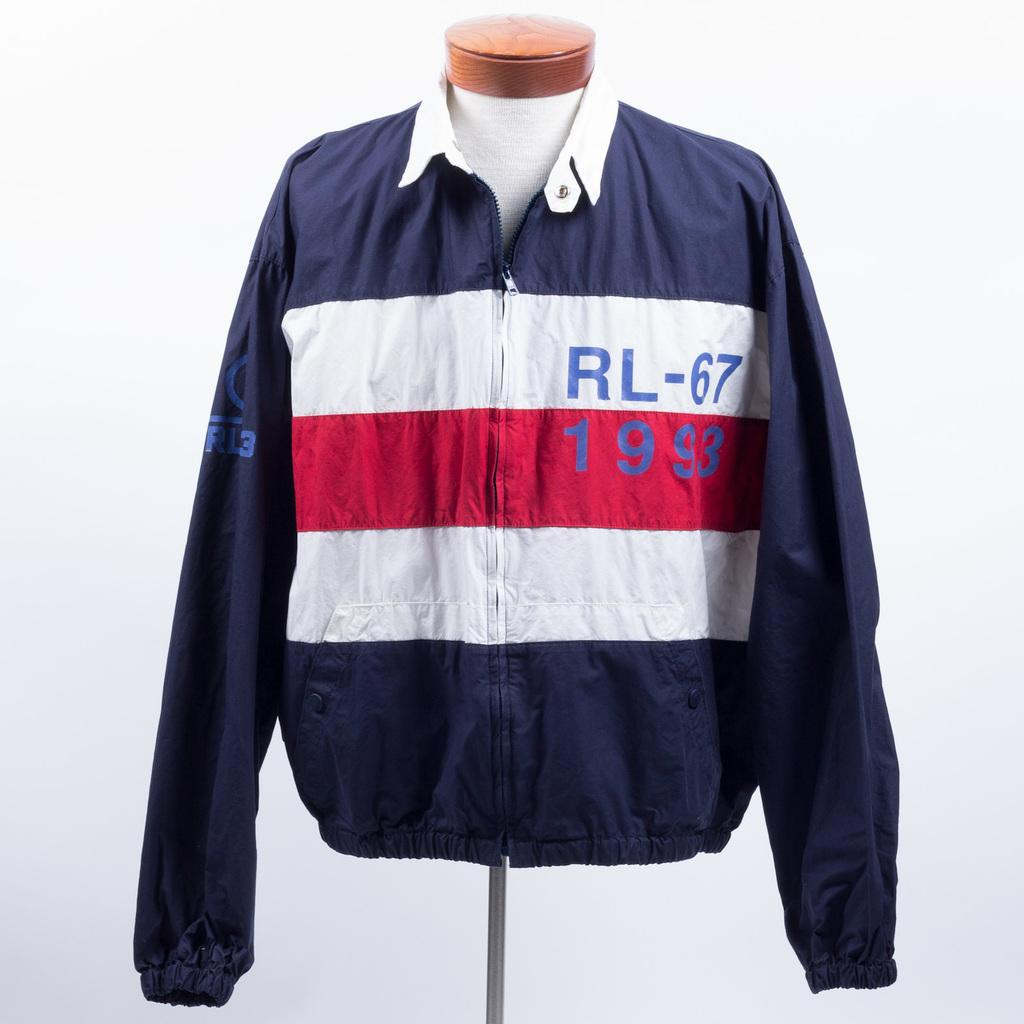Provide a one-sentence caption for the provided image. dark blue jacket with white and red stripes and lettering RL-67 1993. 